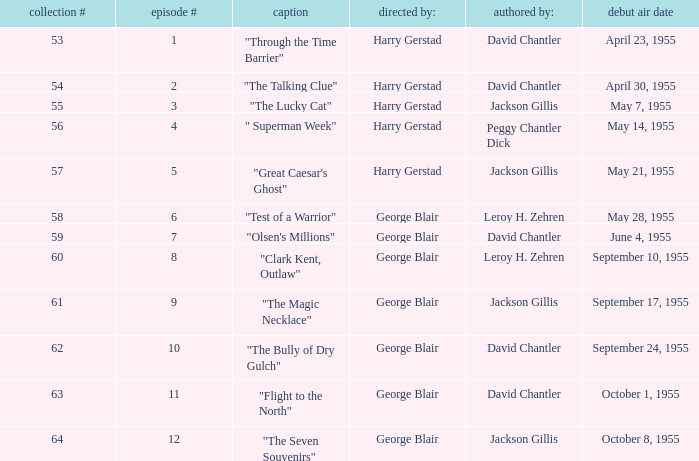What is the lowest number of series? 53.0. 